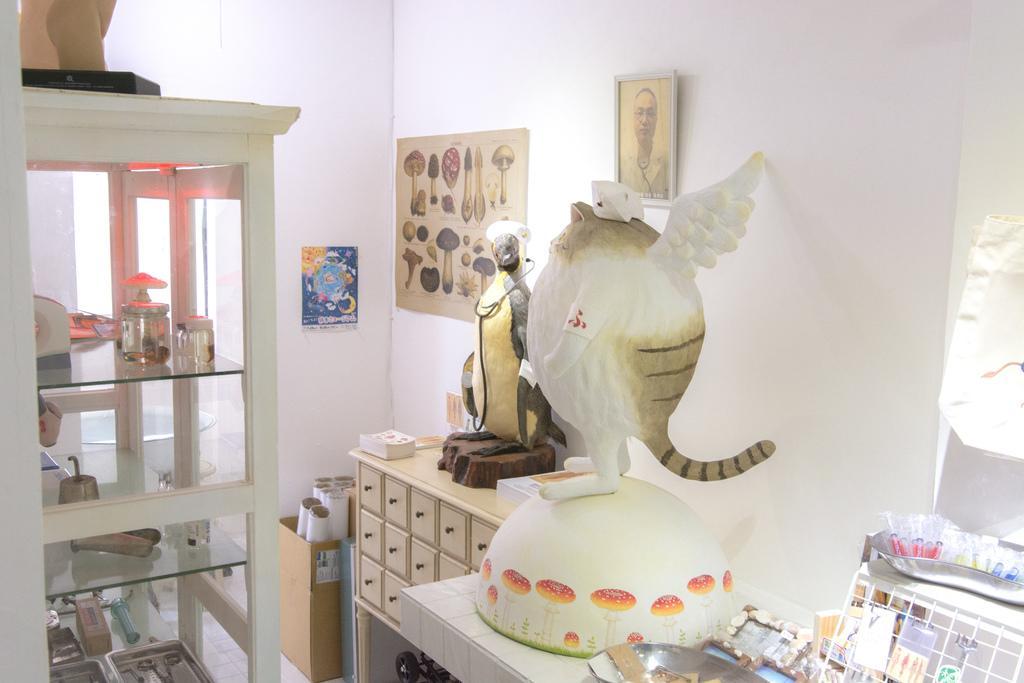Describe this image in one or two sentences. We can see a frame and posters on the wall. On the platforms we can see some showpieces, stethoscope, few objects. On the left side of the picture we can see the objects. We can see some white objects in a cardboard box. 